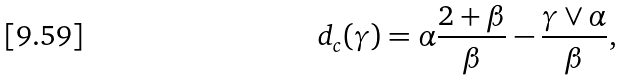Convert formula to latex. <formula><loc_0><loc_0><loc_500><loc_500>d _ { c } ( \gamma ) = \alpha \frac { 2 + \beta } { \beta } - \frac { \gamma \vee \alpha } { \beta } ,</formula> 